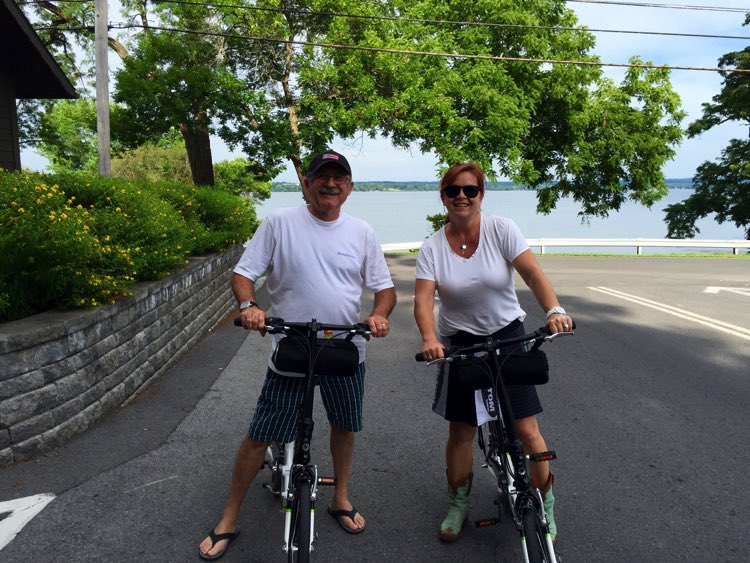Considering the design and features of the bicycles, what type of cycling activity do they seem to be engaged in? Observing the bicycles’ design, which includes upright handlebars and cushioned seats, along with the riders' relaxed attire and the serene lakeside setting, it's clear they are tailored for casual, recreational cycling. Such bikes prioritize comfort and a pleasant riding experience over speed or rough terrain agility, suggesting a leisurely outing, likely enjoying the scenic beauty evidenced by the nearby lake and abundant greenery. 